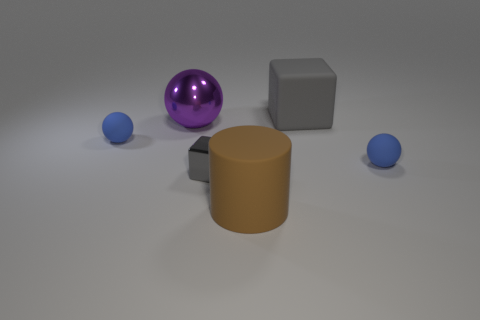How many objects are there, and can you describe their shapes? There are five objects in total: one metallic cube with sharp edges, one shiny sphere, a tall cylinder, and two smaller spheres. Each object has a distinct geometric shape that interacts with the light differently. 